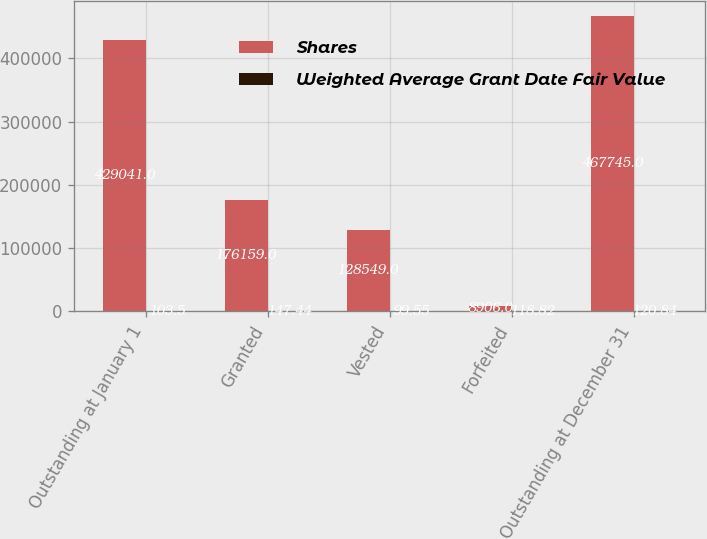<chart> <loc_0><loc_0><loc_500><loc_500><stacked_bar_chart><ecel><fcel>Outstanding at January 1<fcel>Granted<fcel>Vested<fcel>Forfeited<fcel>Outstanding at December 31<nl><fcel>Shares<fcel>429041<fcel>176159<fcel>128549<fcel>8906<fcel>467745<nl><fcel>Weighted Average Grant Date Fair Value<fcel>103.5<fcel>147.44<fcel>99.55<fcel>118.82<fcel>120.84<nl></chart> 